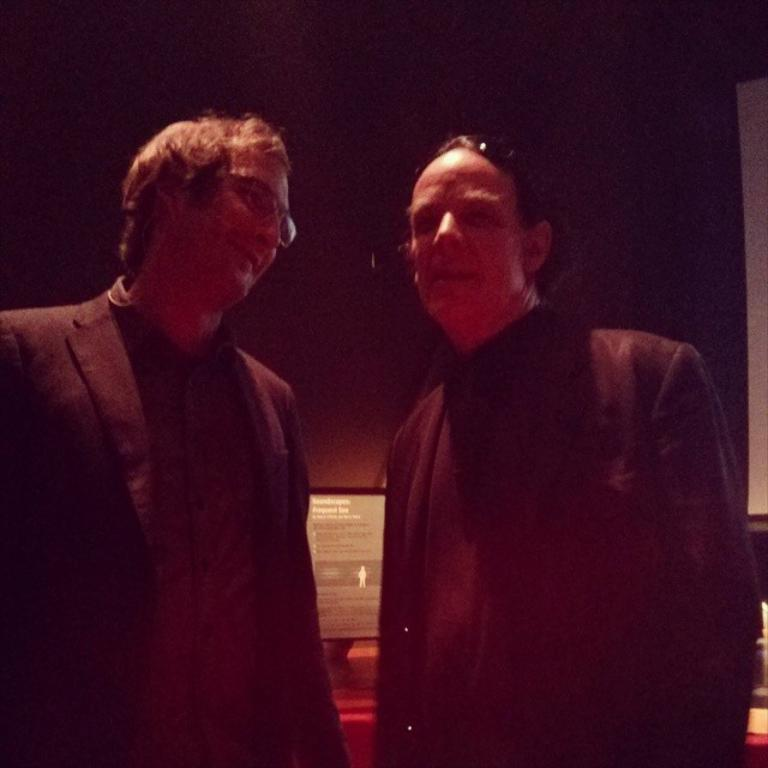How many people are in the image? There are two persons in the image. What are the persons wearing? Both persons are wearing black blazers. What are the persons doing in the image? The persons are standing. What can be seen in the background of the image? There is a monitor in the background of the image. How would you describe the overall appearance of the image? The image has a dark appearance. How many chairs are visible in the image? There are no chairs visible in the image. What type of cellar can be seen in the image? There is no cellar present in the image. 